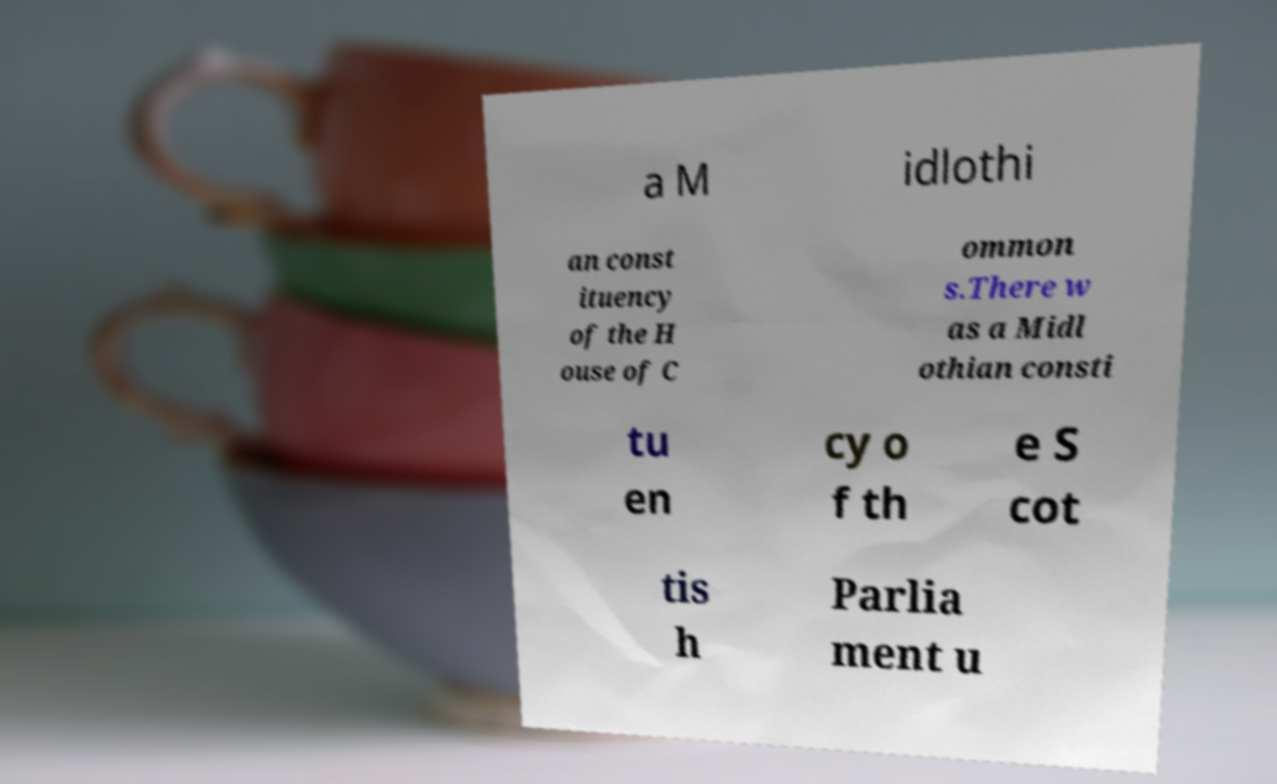I need the written content from this picture converted into text. Can you do that? a M idlothi an const ituency of the H ouse of C ommon s.There w as a Midl othian consti tu en cy o f th e S cot tis h Parlia ment u 